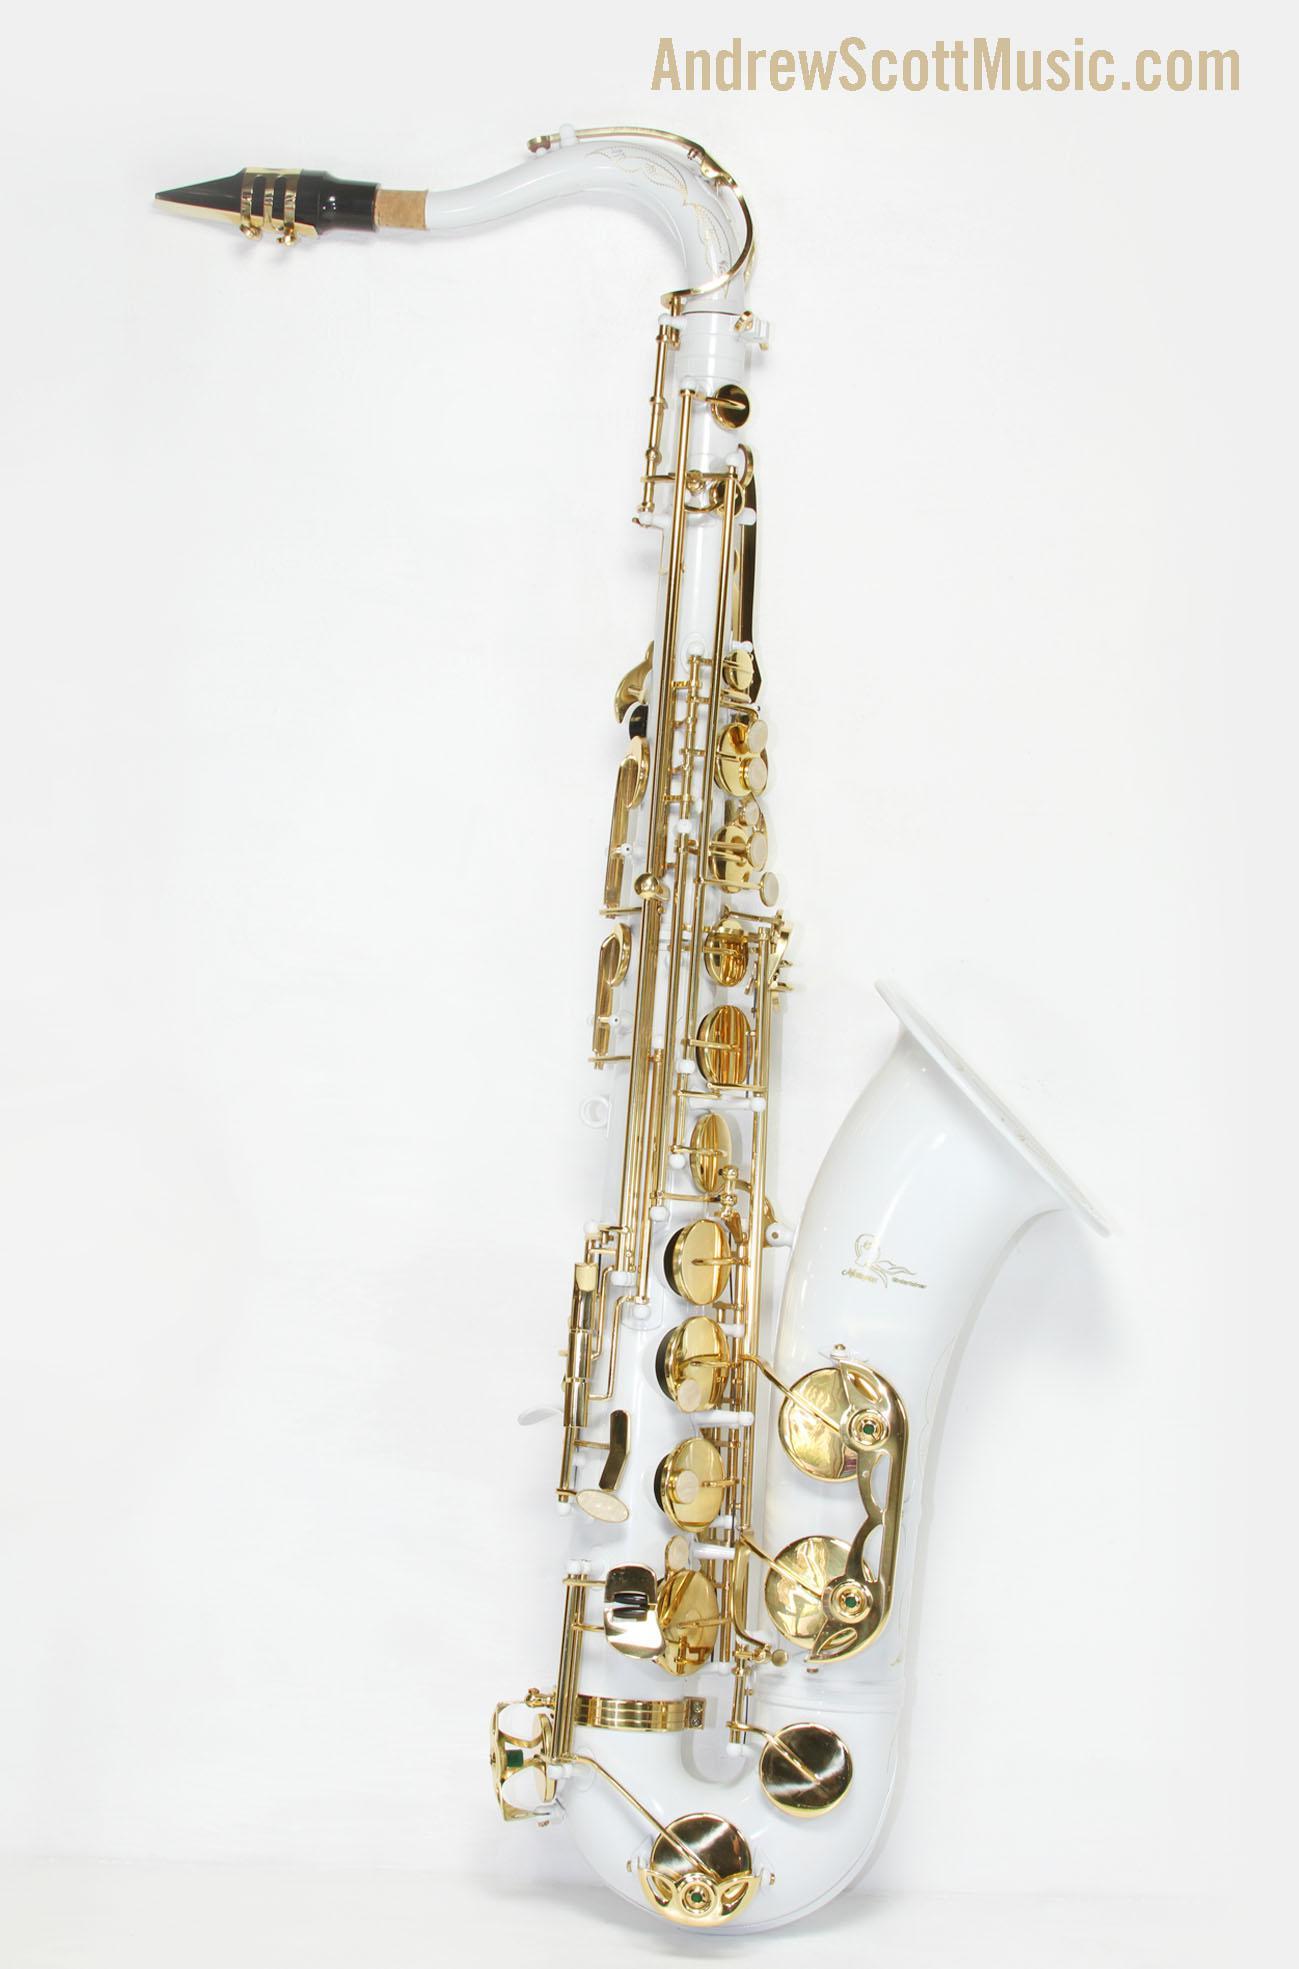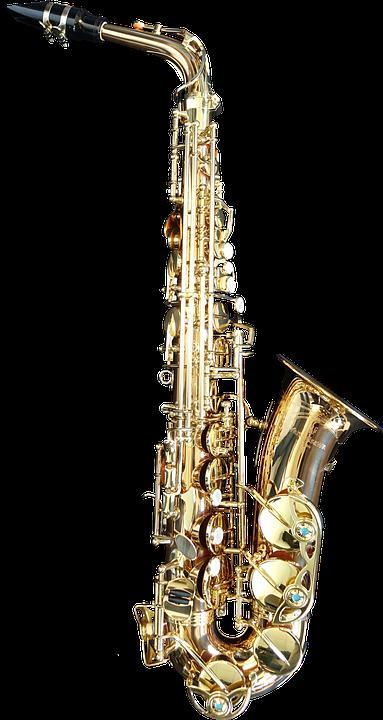The first image is the image on the left, the second image is the image on the right. Assess this claim about the two images: "A gold-colored right-facing saxophone is displayed fully upright on a black background.". Correct or not? Answer yes or no. Yes. 